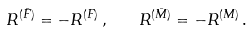Convert formula to latex. <formula><loc_0><loc_0><loc_500><loc_500>R ^ { ( \bar { F } ) } = - R ^ { ( F ) } \, , \quad R ^ { ( \bar { M } ) } = - R ^ { ( M ) } \, .</formula> 